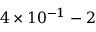Convert formula to latex. <formula><loc_0><loc_0><loc_500><loc_500>4 \times 1 0 ^ { - 1 } - 2</formula> 